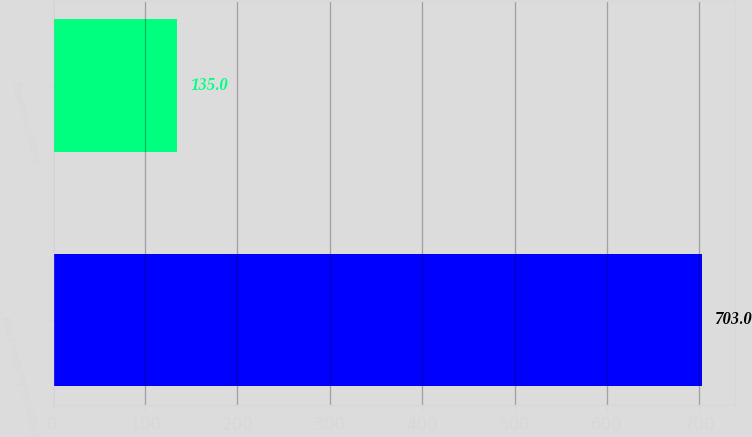Convert chart. <chart><loc_0><loc_0><loc_500><loc_500><bar_chart><fcel>Fixed maturity securities<fcel>Equity securities<nl><fcel>703<fcel>135<nl></chart> 